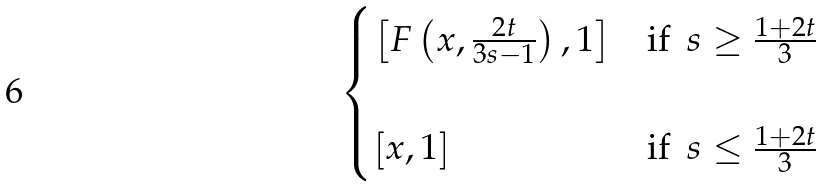<formula> <loc_0><loc_0><loc_500><loc_500>\begin{cases} \left [ F \left ( x , \frac { 2 t } { 3 s - 1 } \right ) , 1 \right ] & \text {if\, $s\geq \frac{1+2t}{3}$} \\ \\ \left [ x , 1 \right ] & \text {if\, $s\leq \frac{1+2t}{3}$} \end{cases}</formula> 